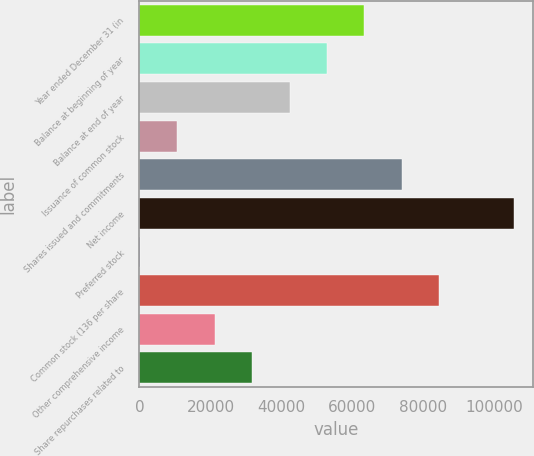Convert chart. <chart><loc_0><loc_0><loc_500><loc_500><bar_chart><fcel>Year ended December 31 (in<fcel>Balance at beginning of year<fcel>Balance at end of year<fcel>Issuance of common stock<fcel>Shares issued and commitments<fcel>Net income<fcel>Preferred stock<fcel>Common stock (136 per share<fcel>Other comprehensive income<fcel>Share repurchases related to<nl><fcel>63412.6<fcel>52852.5<fcel>42292.4<fcel>10612.1<fcel>73972.7<fcel>105653<fcel>52<fcel>84532.8<fcel>21172.2<fcel>31732.3<nl></chart> 